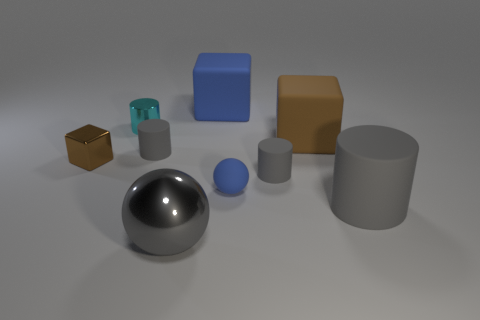Is there a object of the same color as the small block? Yes, there is a larger block in the background that shares the same blue color as the small block in the foreground. This repetition of color among different-sized shapes adds a sense of cohesion to the scene. 